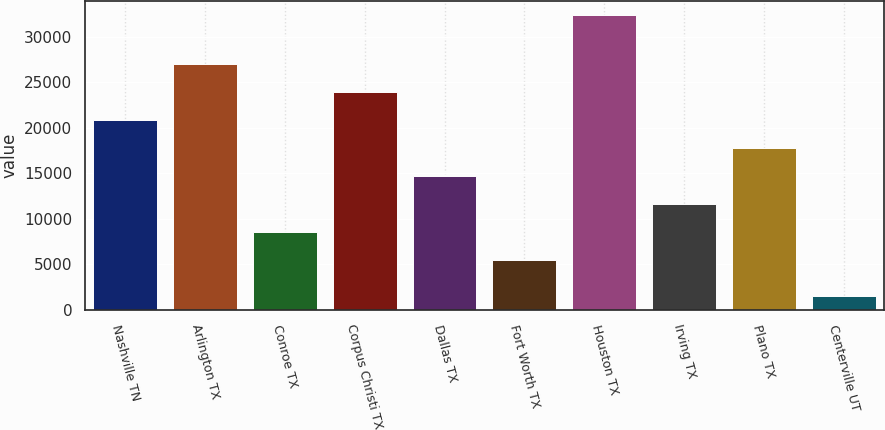Convert chart. <chart><loc_0><loc_0><loc_500><loc_500><bar_chart><fcel>Nashville TN<fcel>Arlington TX<fcel>Conroe TX<fcel>Corpus Christi TX<fcel>Dallas TX<fcel>Fort Worth TX<fcel>Houston TX<fcel>Irving TX<fcel>Plano TX<fcel>Centerville UT<nl><fcel>20865<fcel>27035.4<fcel>8524.2<fcel>23950.2<fcel>14694.6<fcel>5439<fcel>32374<fcel>11609.4<fcel>17779.8<fcel>1522<nl></chart> 